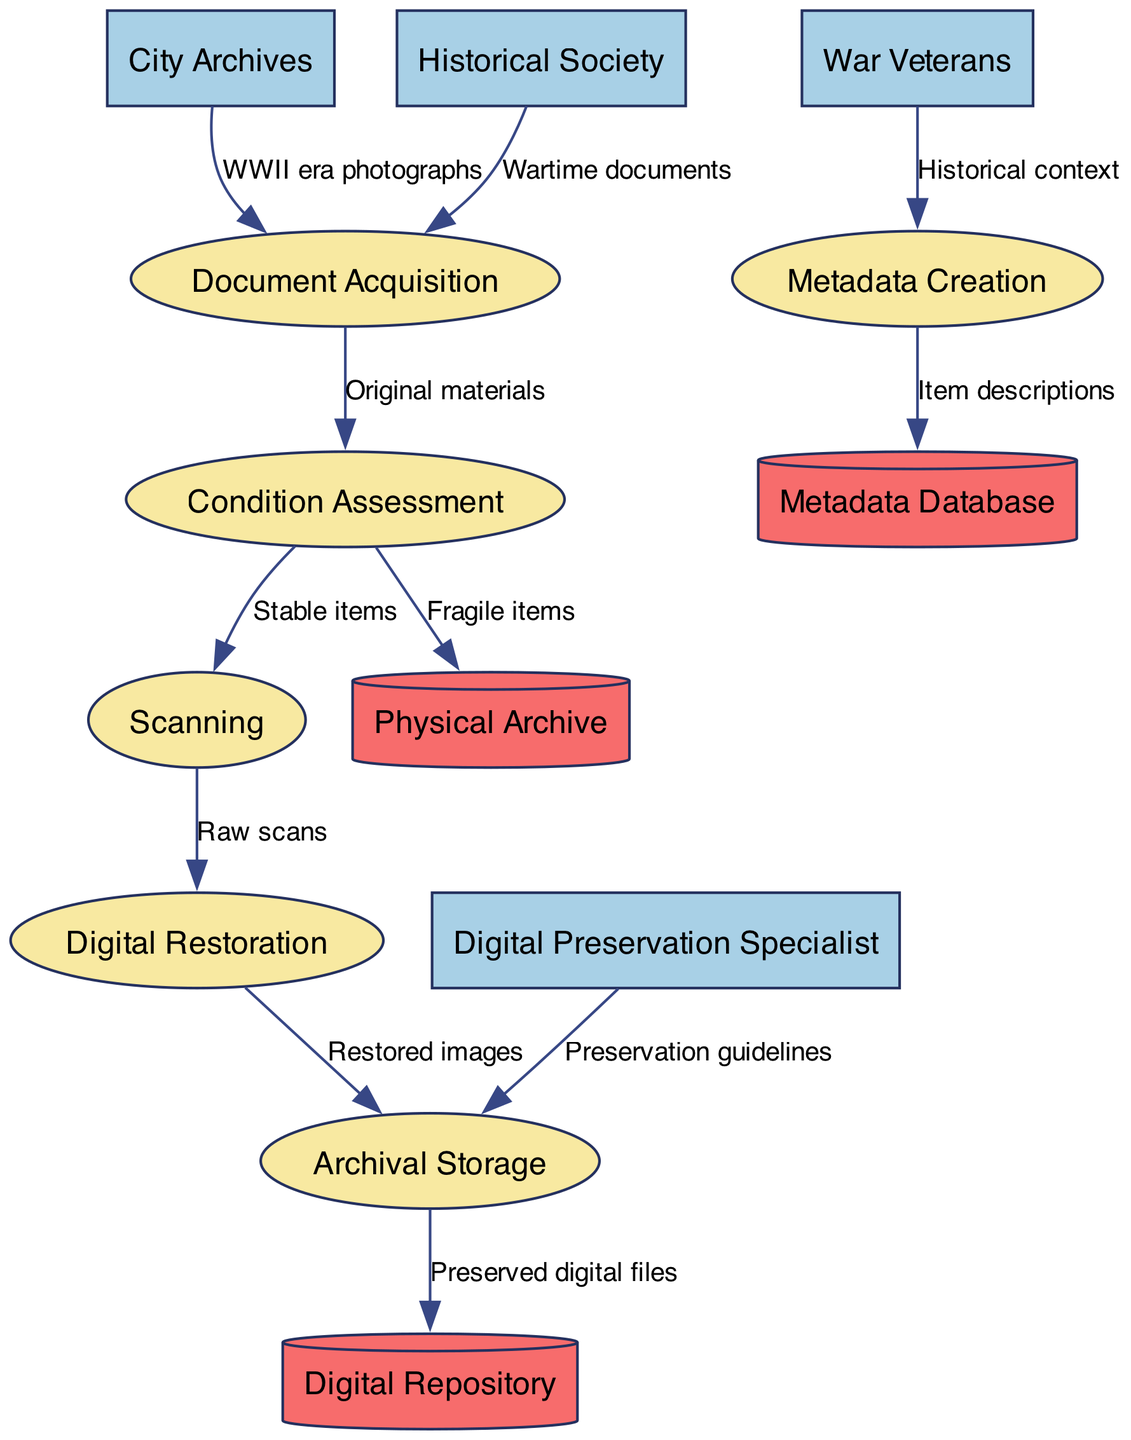What are the external entities involved in this process? The external entities listed in the diagram include the City Archives, Historical Society, War Veterans, and Digital Preservation Specialist.
Answer: City Archives, Historical Society, War Veterans, Digital Preservation Specialist How many processes are in the diagram? The diagram lists six processes: Document Acquisition, Condition Assessment, Metadata Creation, Scanning, Digital Restoration, and Archival Storage. Counting these processes gives a total of six.
Answer: 6 What type of items flow from Condition Assessment to Physical Archive? The label on the data flow from Condition Assessment to Physical Archive indicates that fragile items are sent there, indicating that these materials require careful storage due to their delicate nature.
Answer: Fragile items Which external entity provides historical context for Metadata Creation? The War Veterans are identified as the external entity contributing to Metadata Creation by providing important historical context pertinent to the documents and photographs being preserved.
Answer: War Veterans What is sent from Archival Storage to the Digital Repository? According to the diagram, the data flow from Archival Storage to the Digital Repository indicates that preserved digital files are sent there for further securing and management in the digital space.
Answer: Preserved digital files Which process follows scanning in the flow? Following the scanning process, the subsequent process is Digital Restoration, where the raw scans are enhanced and restored to improve their quality and usability.
Answer: Digital Restoration What type of input is required for the Document Acquisition process? The input required for Document Acquisition includes WWII era photographs from the City Archives and wartime documents from the Historical Society, both crucial for initiation of the preservation efforts.
Answer: WWII era photographs, Wartime documents Which data store receives item descriptions from Metadata Creation? The Metadata Database receives item descriptions from the Metadata Creation process, serving as a critical component in cataloging and indexing digital assets being preserved.
Answer: Metadata Database How many data stores are present in the diagram? The diagram includes three data stores: Physical Archive, Digital Repository, and Metadata Database. Counting these reveals a total of three data stores in the process flow.
Answer: 3 What type of guidelines flow from the Digital Preservation Specialist to Archival Storage? The flow from the Digital Preservation Specialist to Archival Storage consists of preservation guidelines, which are essential for maintaining the integrity and longevity of the archival materials.
Answer: Preservation guidelines 